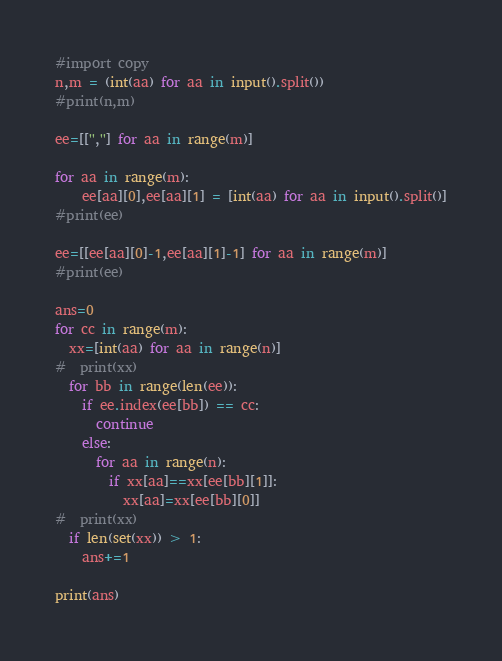<code> <loc_0><loc_0><loc_500><loc_500><_Python_>#import copy
n,m = (int(aa) for aa in input().split())
#print(n,m)

ee=[['',''] for aa in range(m)]

for aa in range(m):
    ee[aa][0],ee[aa][1] = [int(aa) for aa in input().split()]
#print(ee)

ee=[[ee[aa][0]-1,ee[aa][1]-1] for aa in range(m)]
#print(ee)

ans=0
for cc in range(m):
  xx=[int(aa) for aa in range(n)]
#  print(xx)
  for bb in range(len(ee)):
    if ee.index(ee[bb]) == cc:
      continue
    else:
      for aa in range(n):
        if xx[aa]==xx[ee[bb][1]]:
          xx[aa]=xx[ee[bb][0]]
#  print(xx)
  if len(set(xx)) > 1:
    ans+=1
    
print(ans)
</code> 